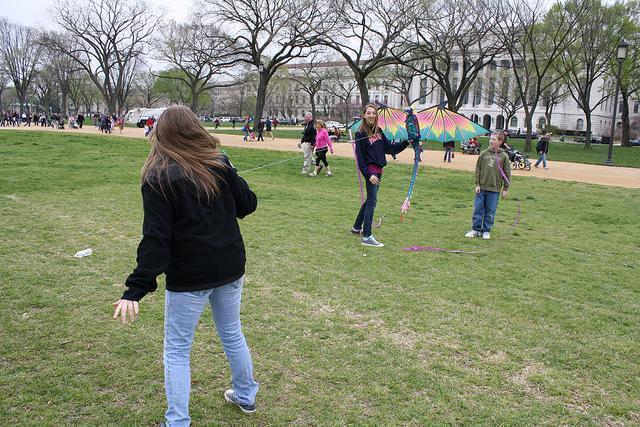How many people are visible?
Give a very brief answer. 4. 